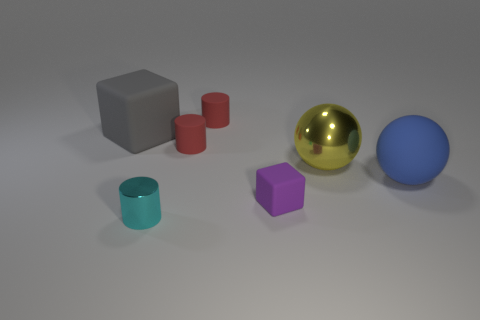Is there anything else that has the same material as the small purple thing?
Give a very brief answer. Yes. How many tiny red shiny objects are there?
Make the answer very short. 0. Is the color of the tiny matte cube the same as the small shiny cylinder?
Your answer should be very brief. No. There is a big thing that is both behind the big matte sphere and right of the gray rubber thing; what is its color?
Provide a short and direct response. Yellow. There is a matte sphere; are there any big blue things left of it?
Give a very brief answer. No. There is a large sphere in front of the big yellow ball; what number of objects are on the left side of it?
Offer a terse response. 6. The other block that is the same material as the small cube is what size?
Provide a short and direct response. Large. What size is the purple rubber cube?
Offer a very short reply. Small. Are the blue ball and the yellow thing made of the same material?
Keep it short and to the point. No. What number of cubes are either yellow metallic things or large gray things?
Ensure brevity in your answer.  1. 